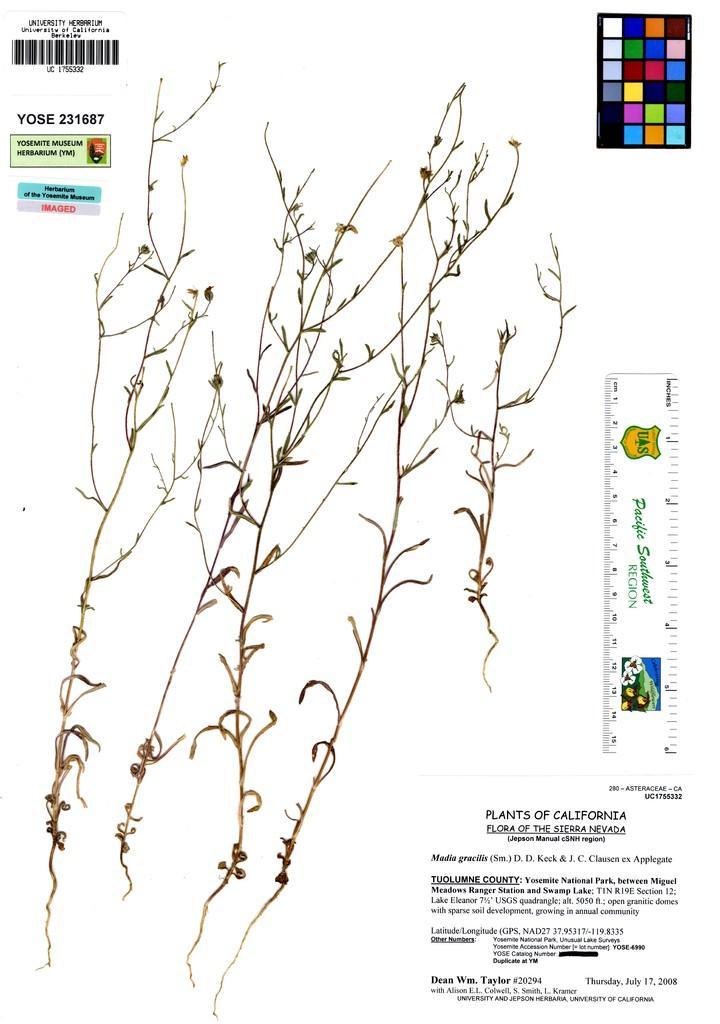How would you summarize this image in a sentence or two? In this image I can see few plants which are brown in color and the white colored background. I can see few words written, a scale, a barcode and few other items. 